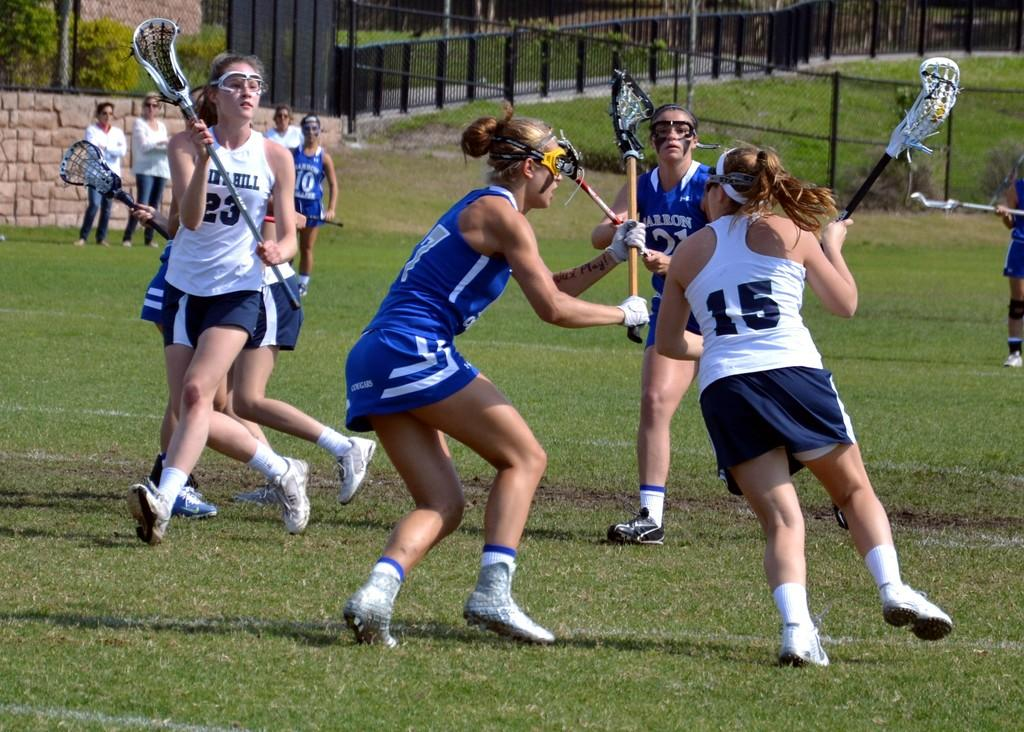What sport are the women playing in the image? The women are playing lacrosse in the image. What type of surface are they playing on? There is grass on the ground in the image. Can you describe the background of the image? There are people visible in the background of the image. What is the boundary of the playing area in the image? There is a fence in the image. How does the attention of the women playing lacrosse change throughout the game in the image? The image does not show any changes in the women's attention or the progression of the game, so it cannot be determined from the image. 